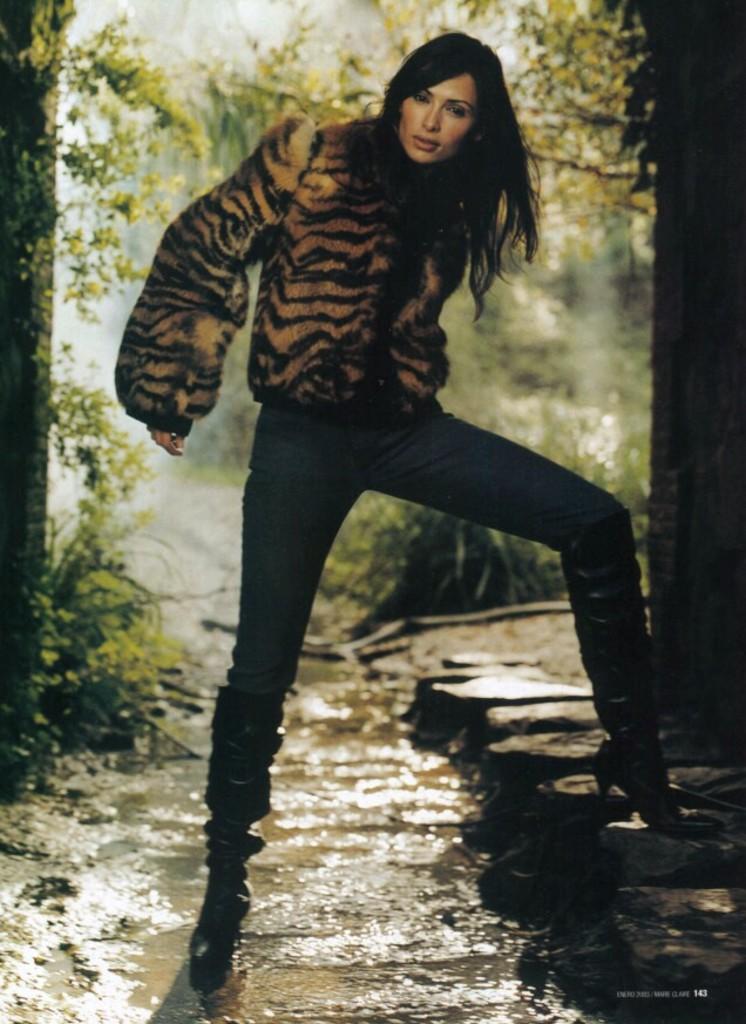Can you describe this image briefly? In this picture I can see a woman standing, there is water, and in the background there are trees. 